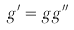<formula> <loc_0><loc_0><loc_500><loc_500>g ^ { \prime } = g g ^ { \prime \prime }</formula> 